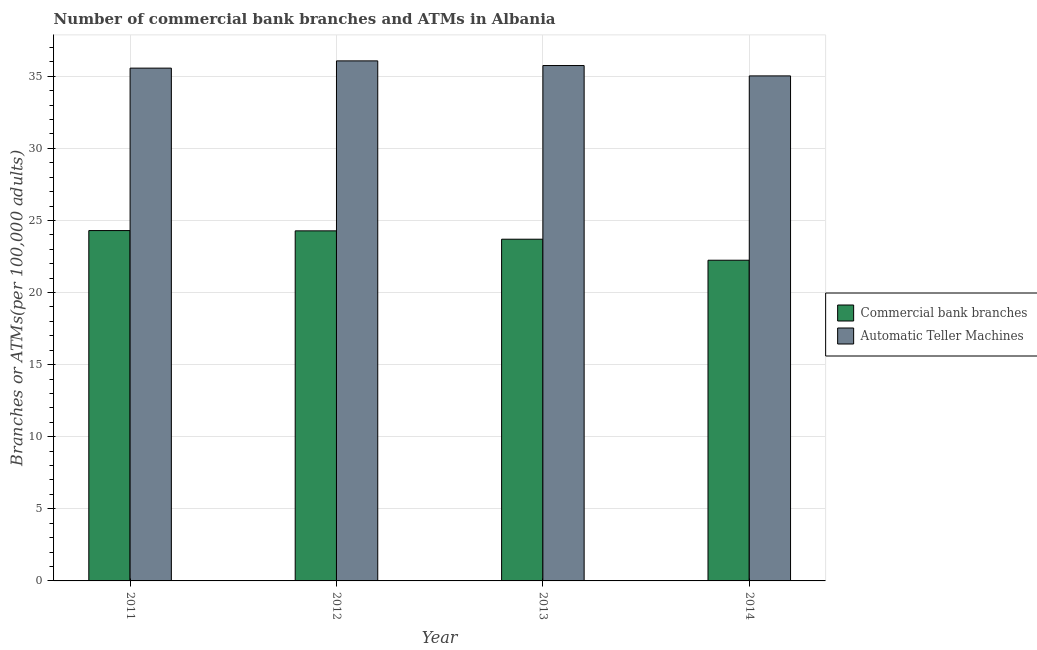In how many cases, is the number of bars for a given year not equal to the number of legend labels?
Offer a terse response. 0. What is the number of commercal bank branches in 2011?
Your response must be concise. 24.3. Across all years, what is the maximum number of atms?
Provide a short and direct response. 36.07. Across all years, what is the minimum number of commercal bank branches?
Keep it short and to the point. 22.24. In which year was the number of commercal bank branches minimum?
Provide a short and direct response. 2014. What is the total number of commercal bank branches in the graph?
Keep it short and to the point. 94.52. What is the difference between the number of atms in 2012 and that in 2013?
Your response must be concise. 0.32. What is the difference between the number of commercal bank branches in 2014 and the number of atms in 2013?
Keep it short and to the point. -1.46. What is the average number of commercal bank branches per year?
Offer a very short reply. 23.63. What is the ratio of the number of commercal bank branches in 2011 to that in 2012?
Ensure brevity in your answer.  1. Is the number of atms in 2013 less than that in 2014?
Provide a short and direct response. No. What is the difference between the highest and the second highest number of atms?
Provide a succinct answer. 0.32. What is the difference between the highest and the lowest number of commercal bank branches?
Your answer should be very brief. 2.06. Is the sum of the number of atms in 2013 and 2014 greater than the maximum number of commercal bank branches across all years?
Keep it short and to the point. Yes. What does the 1st bar from the left in 2013 represents?
Your answer should be compact. Commercial bank branches. What does the 2nd bar from the right in 2014 represents?
Give a very brief answer. Commercial bank branches. How many bars are there?
Keep it short and to the point. 8. How many years are there in the graph?
Make the answer very short. 4. Are the values on the major ticks of Y-axis written in scientific E-notation?
Offer a very short reply. No. Where does the legend appear in the graph?
Make the answer very short. Center right. How are the legend labels stacked?
Your answer should be compact. Vertical. What is the title of the graph?
Give a very brief answer. Number of commercial bank branches and ATMs in Albania. Does "Quality of trade" appear as one of the legend labels in the graph?
Your answer should be compact. No. What is the label or title of the Y-axis?
Make the answer very short. Branches or ATMs(per 100,0 adults). What is the Branches or ATMs(per 100,000 adults) of Commercial bank branches in 2011?
Your answer should be very brief. 24.3. What is the Branches or ATMs(per 100,000 adults) of Automatic Teller Machines in 2011?
Offer a terse response. 35.56. What is the Branches or ATMs(per 100,000 adults) of Commercial bank branches in 2012?
Ensure brevity in your answer.  24.28. What is the Branches or ATMs(per 100,000 adults) of Automatic Teller Machines in 2012?
Your answer should be very brief. 36.07. What is the Branches or ATMs(per 100,000 adults) in Commercial bank branches in 2013?
Ensure brevity in your answer.  23.7. What is the Branches or ATMs(per 100,000 adults) in Automatic Teller Machines in 2013?
Keep it short and to the point. 35.74. What is the Branches or ATMs(per 100,000 adults) in Commercial bank branches in 2014?
Keep it short and to the point. 22.24. What is the Branches or ATMs(per 100,000 adults) of Automatic Teller Machines in 2014?
Make the answer very short. 35.03. Across all years, what is the maximum Branches or ATMs(per 100,000 adults) in Commercial bank branches?
Your answer should be compact. 24.3. Across all years, what is the maximum Branches or ATMs(per 100,000 adults) of Automatic Teller Machines?
Ensure brevity in your answer.  36.07. Across all years, what is the minimum Branches or ATMs(per 100,000 adults) of Commercial bank branches?
Provide a short and direct response. 22.24. Across all years, what is the minimum Branches or ATMs(per 100,000 adults) of Automatic Teller Machines?
Provide a succinct answer. 35.03. What is the total Branches or ATMs(per 100,000 adults) of Commercial bank branches in the graph?
Offer a very short reply. 94.52. What is the total Branches or ATMs(per 100,000 adults) in Automatic Teller Machines in the graph?
Keep it short and to the point. 142.4. What is the difference between the Branches or ATMs(per 100,000 adults) of Commercial bank branches in 2011 and that in 2012?
Offer a terse response. 0.02. What is the difference between the Branches or ATMs(per 100,000 adults) of Automatic Teller Machines in 2011 and that in 2012?
Offer a terse response. -0.5. What is the difference between the Branches or ATMs(per 100,000 adults) in Commercial bank branches in 2011 and that in 2013?
Ensure brevity in your answer.  0.6. What is the difference between the Branches or ATMs(per 100,000 adults) of Automatic Teller Machines in 2011 and that in 2013?
Ensure brevity in your answer.  -0.18. What is the difference between the Branches or ATMs(per 100,000 adults) of Commercial bank branches in 2011 and that in 2014?
Your answer should be very brief. 2.06. What is the difference between the Branches or ATMs(per 100,000 adults) in Automatic Teller Machines in 2011 and that in 2014?
Offer a terse response. 0.54. What is the difference between the Branches or ATMs(per 100,000 adults) of Commercial bank branches in 2012 and that in 2013?
Provide a succinct answer. 0.58. What is the difference between the Branches or ATMs(per 100,000 adults) in Automatic Teller Machines in 2012 and that in 2013?
Offer a very short reply. 0.32. What is the difference between the Branches or ATMs(per 100,000 adults) of Commercial bank branches in 2012 and that in 2014?
Offer a terse response. 2.04. What is the difference between the Branches or ATMs(per 100,000 adults) in Automatic Teller Machines in 2012 and that in 2014?
Your answer should be compact. 1.04. What is the difference between the Branches or ATMs(per 100,000 adults) of Commercial bank branches in 2013 and that in 2014?
Provide a succinct answer. 1.46. What is the difference between the Branches or ATMs(per 100,000 adults) in Automatic Teller Machines in 2013 and that in 2014?
Ensure brevity in your answer.  0.72. What is the difference between the Branches or ATMs(per 100,000 adults) of Commercial bank branches in 2011 and the Branches or ATMs(per 100,000 adults) of Automatic Teller Machines in 2012?
Make the answer very short. -11.77. What is the difference between the Branches or ATMs(per 100,000 adults) of Commercial bank branches in 2011 and the Branches or ATMs(per 100,000 adults) of Automatic Teller Machines in 2013?
Provide a short and direct response. -11.45. What is the difference between the Branches or ATMs(per 100,000 adults) of Commercial bank branches in 2011 and the Branches or ATMs(per 100,000 adults) of Automatic Teller Machines in 2014?
Ensure brevity in your answer.  -10.73. What is the difference between the Branches or ATMs(per 100,000 adults) of Commercial bank branches in 2012 and the Branches or ATMs(per 100,000 adults) of Automatic Teller Machines in 2013?
Offer a very short reply. -11.47. What is the difference between the Branches or ATMs(per 100,000 adults) in Commercial bank branches in 2012 and the Branches or ATMs(per 100,000 adults) in Automatic Teller Machines in 2014?
Make the answer very short. -10.75. What is the difference between the Branches or ATMs(per 100,000 adults) in Commercial bank branches in 2013 and the Branches or ATMs(per 100,000 adults) in Automatic Teller Machines in 2014?
Make the answer very short. -11.33. What is the average Branches or ATMs(per 100,000 adults) in Commercial bank branches per year?
Offer a terse response. 23.63. What is the average Branches or ATMs(per 100,000 adults) in Automatic Teller Machines per year?
Give a very brief answer. 35.6. In the year 2011, what is the difference between the Branches or ATMs(per 100,000 adults) in Commercial bank branches and Branches or ATMs(per 100,000 adults) in Automatic Teller Machines?
Keep it short and to the point. -11.27. In the year 2012, what is the difference between the Branches or ATMs(per 100,000 adults) of Commercial bank branches and Branches or ATMs(per 100,000 adults) of Automatic Teller Machines?
Your answer should be compact. -11.79. In the year 2013, what is the difference between the Branches or ATMs(per 100,000 adults) of Commercial bank branches and Branches or ATMs(per 100,000 adults) of Automatic Teller Machines?
Offer a terse response. -12.05. In the year 2014, what is the difference between the Branches or ATMs(per 100,000 adults) of Commercial bank branches and Branches or ATMs(per 100,000 adults) of Automatic Teller Machines?
Give a very brief answer. -12.78. What is the ratio of the Branches or ATMs(per 100,000 adults) of Commercial bank branches in 2011 to that in 2012?
Your response must be concise. 1. What is the ratio of the Branches or ATMs(per 100,000 adults) in Commercial bank branches in 2011 to that in 2013?
Ensure brevity in your answer.  1.03. What is the ratio of the Branches or ATMs(per 100,000 adults) in Automatic Teller Machines in 2011 to that in 2013?
Your answer should be very brief. 0.99. What is the ratio of the Branches or ATMs(per 100,000 adults) of Commercial bank branches in 2011 to that in 2014?
Offer a terse response. 1.09. What is the ratio of the Branches or ATMs(per 100,000 adults) of Automatic Teller Machines in 2011 to that in 2014?
Give a very brief answer. 1.02. What is the ratio of the Branches or ATMs(per 100,000 adults) of Commercial bank branches in 2012 to that in 2013?
Your response must be concise. 1.02. What is the ratio of the Branches or ATMs(per 100,000 adults) of Commercial bank branches in 2012 to that in 2014?
Your answer should be very brief. 1.09. What is the ratio of the Branches or ATMs(per 100,000 adults) of Automatic Teller Machines in 2012 to that in 2014?
Keep it short and to the point. 1.03. What is the ratio of the Branches or ATMs(per 100,000 adults) in Commercial bank branches in 2013 to that in 2014?
Keep it short and to the point. 1.07. What is the ratio of the Branches or ATMs(per 100,000 adults) of Automatic Teller Machines in 2013 to that in 2014?
Provide a short and direct response. 1.02. What is the difference between the highest and the second highest Branches or ATMs(per 100,000 adults) of Commercial bank branches?
Provide a short and direct response. 0.02. What is the difference between the highest and the second highest Branches or ATMs(per 100,000 adults) of Automatic Teller Machines?
Your answer should be compact. 0.32. What is the difference between the highest and the lowest Branches or ATMs(per 100,000 adults) in Commercial bank branches?
Provide a short and direct response. 2.06. What is the difference between the highest and the lowest Branches or ATMs(per 100,000 adults) in Automatic Teller Machines?
Keep it short and to the point. 1.04. 